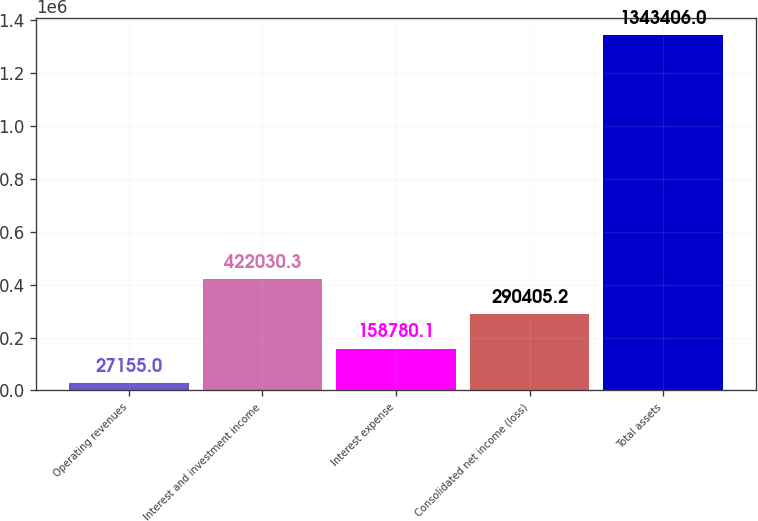<chart> <loc_0><loc_0><loc_500><loc_500><bar_chart><fcel>Operating revenues<fcel>Interest and investment income<fcel>Interest expense<fcel>Consolidated net income (loss)<fcel>Total assets<nl><fcel>27155<fcel>422030<fcel>158780<fcel>290405<fcel>1.34341e+06<nl></chart> 